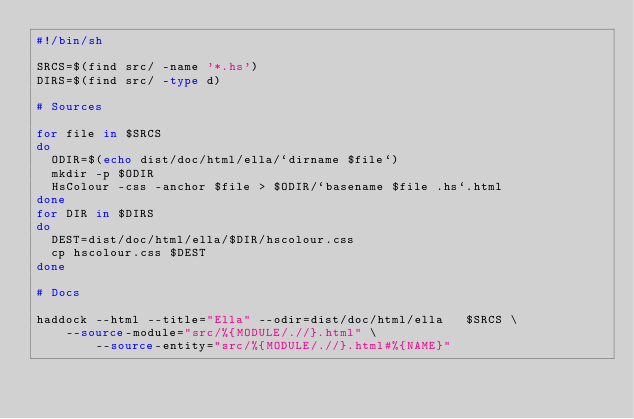<code> <loc_0><loc_0><loc_500><loc_500><_Bash_>#!/bin/sh

SRCS=$(find src/ -name '*.hs')
DIRS=$(find src/ -type d)

# Sources

for file in $SRCS 
do 
	ODIR=$(echo dist/doc/html/ella/`dirname $file`)
	mkdir -p $ODIR
	HsColour -css -anchor $file > $ODIR/`basename $file .hs`.html
done
for DIR in $DIRS
do
	DEST=dist/doc/html/ella/$DIR/hscolour.css
	cp hscolour.css $DEST
done

# Docs

haddock --html --title="Ella" --odir=dist/doc/html/ella   $SRCS \
    --source-module="src/%{MODULE/.//}.html" \
        --source-entity="src/%{MODULE/.//}.html#%{NAME}"
</code> 